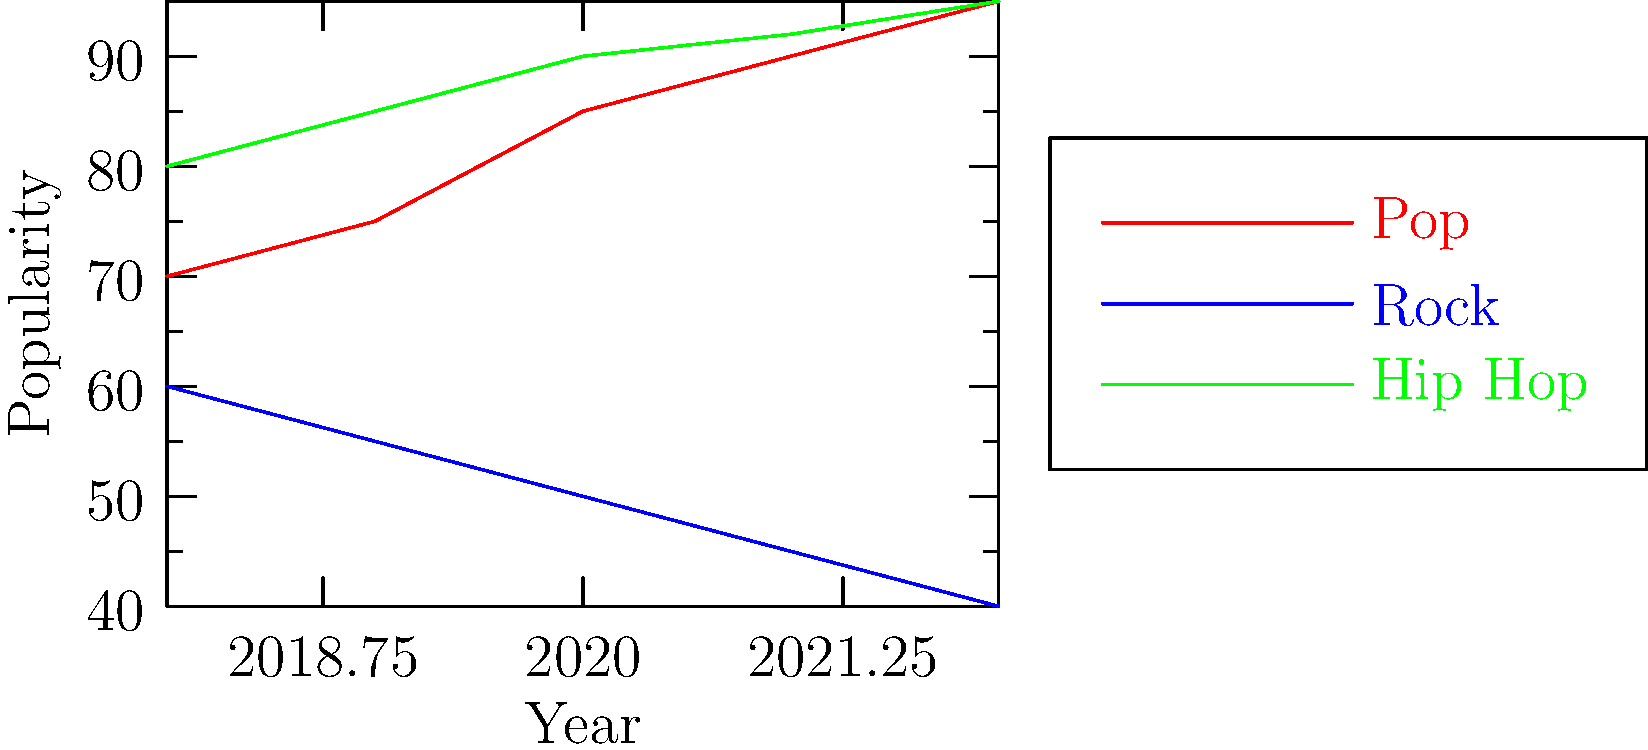As an aspiring pop artist, you're analyzing music genre popularity trends to strategize your career. The graph shows the popularity of Pop, Rock, and Hip Hop from 2018 to 2022. If these trends continue, which genre is most likely to surpass Pop in popularity by 2023, and by approximately how many popularity points? To answer this question, we need to analyze the trends for each genre and compare them to Pop:

1. Pop (red line):
   - Starts at 70 in 2018 and reaches 95 in 2022
   - Shows a steady increase of about 5-10 points per year

2. Rock (blue line):
   - Starts at 60 in 2018 and decreases to 40 in 2022
   - Shows a consistent decline of about 5 points per year

3. Hip Hop (green line):
   - Starts at 80 in 2018 and reaches 95 in 2022
   - Shows a rapid increase, matching Pop by 2022

Comparing the trends:
- Rock is declining, so it's unlikely to surpass Pop
- Hip Hop is increasing at a faster rate than Pop

Projecting to 2023:
- Pop might reach around 100 points (95 + 5)
- Hip Hop is likely to continue its upward trend, potentially reaching 97-98 points

Therefore, Hip Hop is most likely to surpass Pop in 2023. The difference would be approximately 2-3 popularity points higher than Pop.
Answer: Hip Hop, by approximately 2-3 points. 